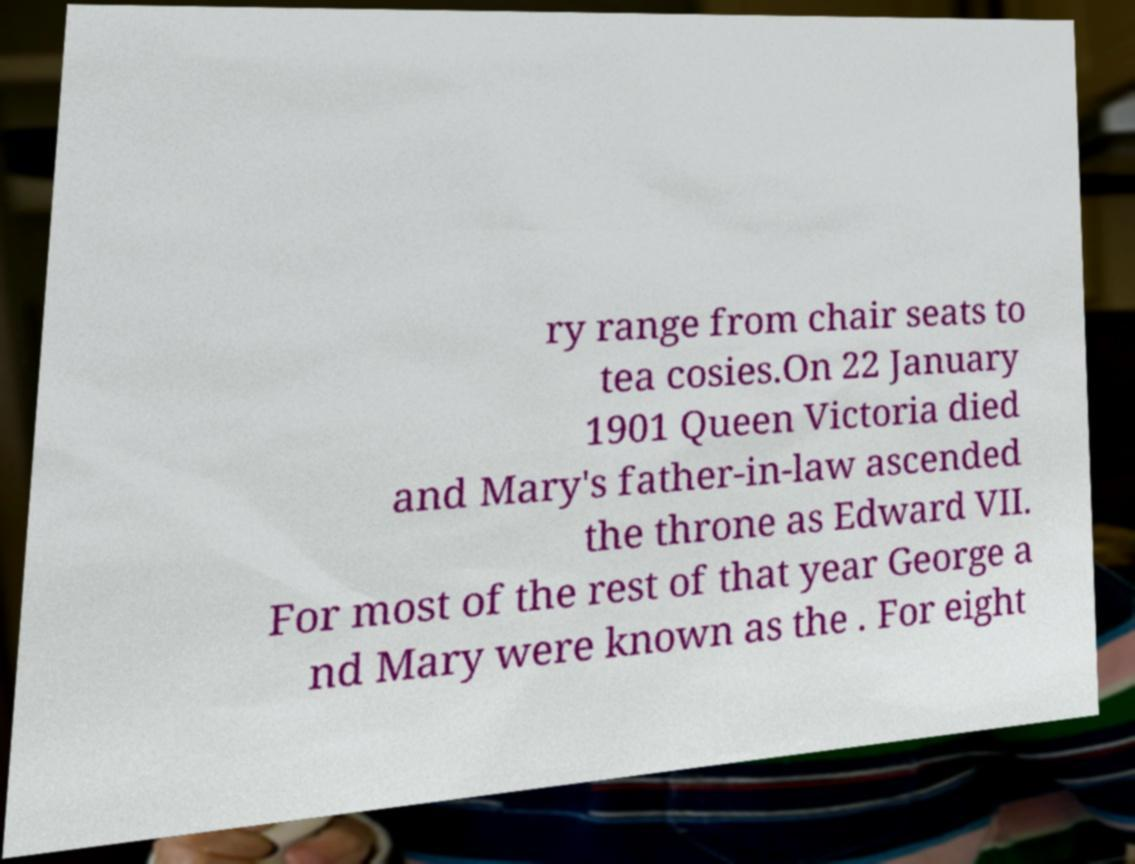For documentation purposes, I need the text within this image transcribed. Could you provide that? ry range from chair seats to tea cosies.On 22 January 1901 Queen Victoria died and Mary's father-in-law ascended the throne as Edward VII. For most of the rest of that year George a nd Mary were known as the . For eight 